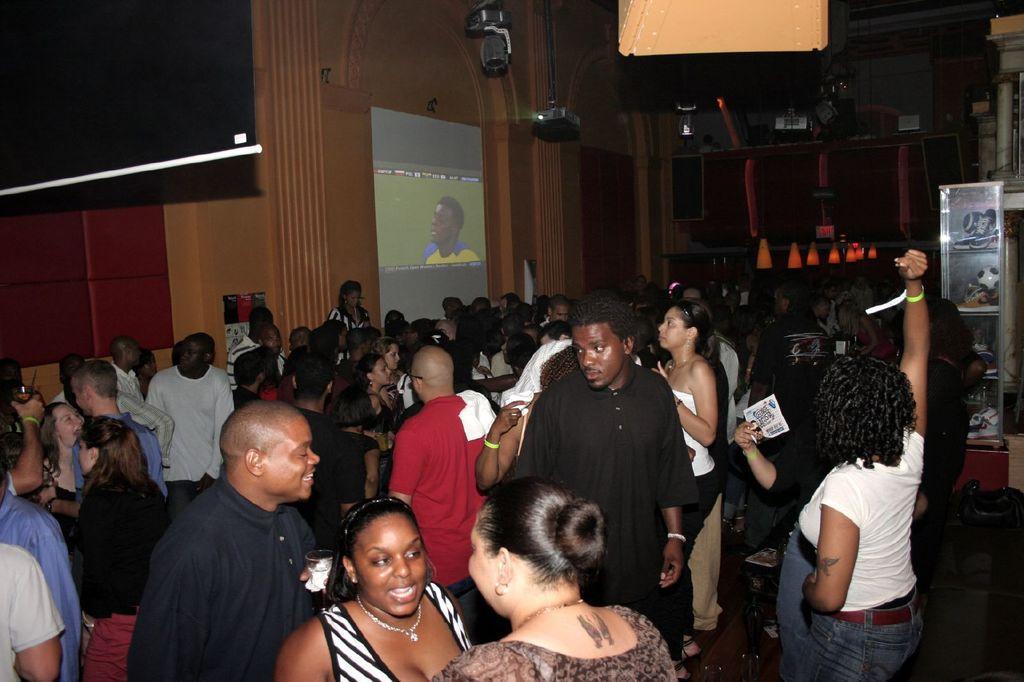How would you summarize this image in a sentence or two? There are group of people standing. I can see the projector and the roof. This is the screen with the display. I think this is the rack with few objects in it. This looks like a speaker, which is attached to the wall. I think this is a board. 